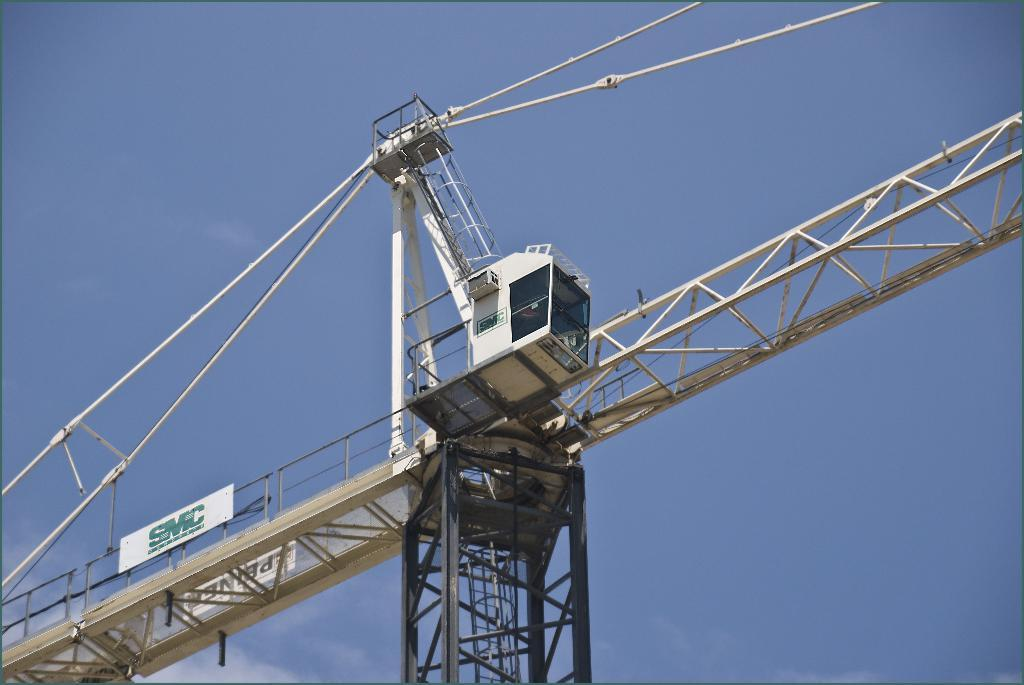What is the main subject of the image? There is a huge crane in the image. What is the purpose of the crane in the image? The crane is used in the construction of massive buildings. How many marks can be seen on the crane in the image? There are no marks visible on the crane in the image. What type of clocks are used to control the crane's movements in the image? There are no clocks present in the image, and the crane's movements are not controlled by clocks. 